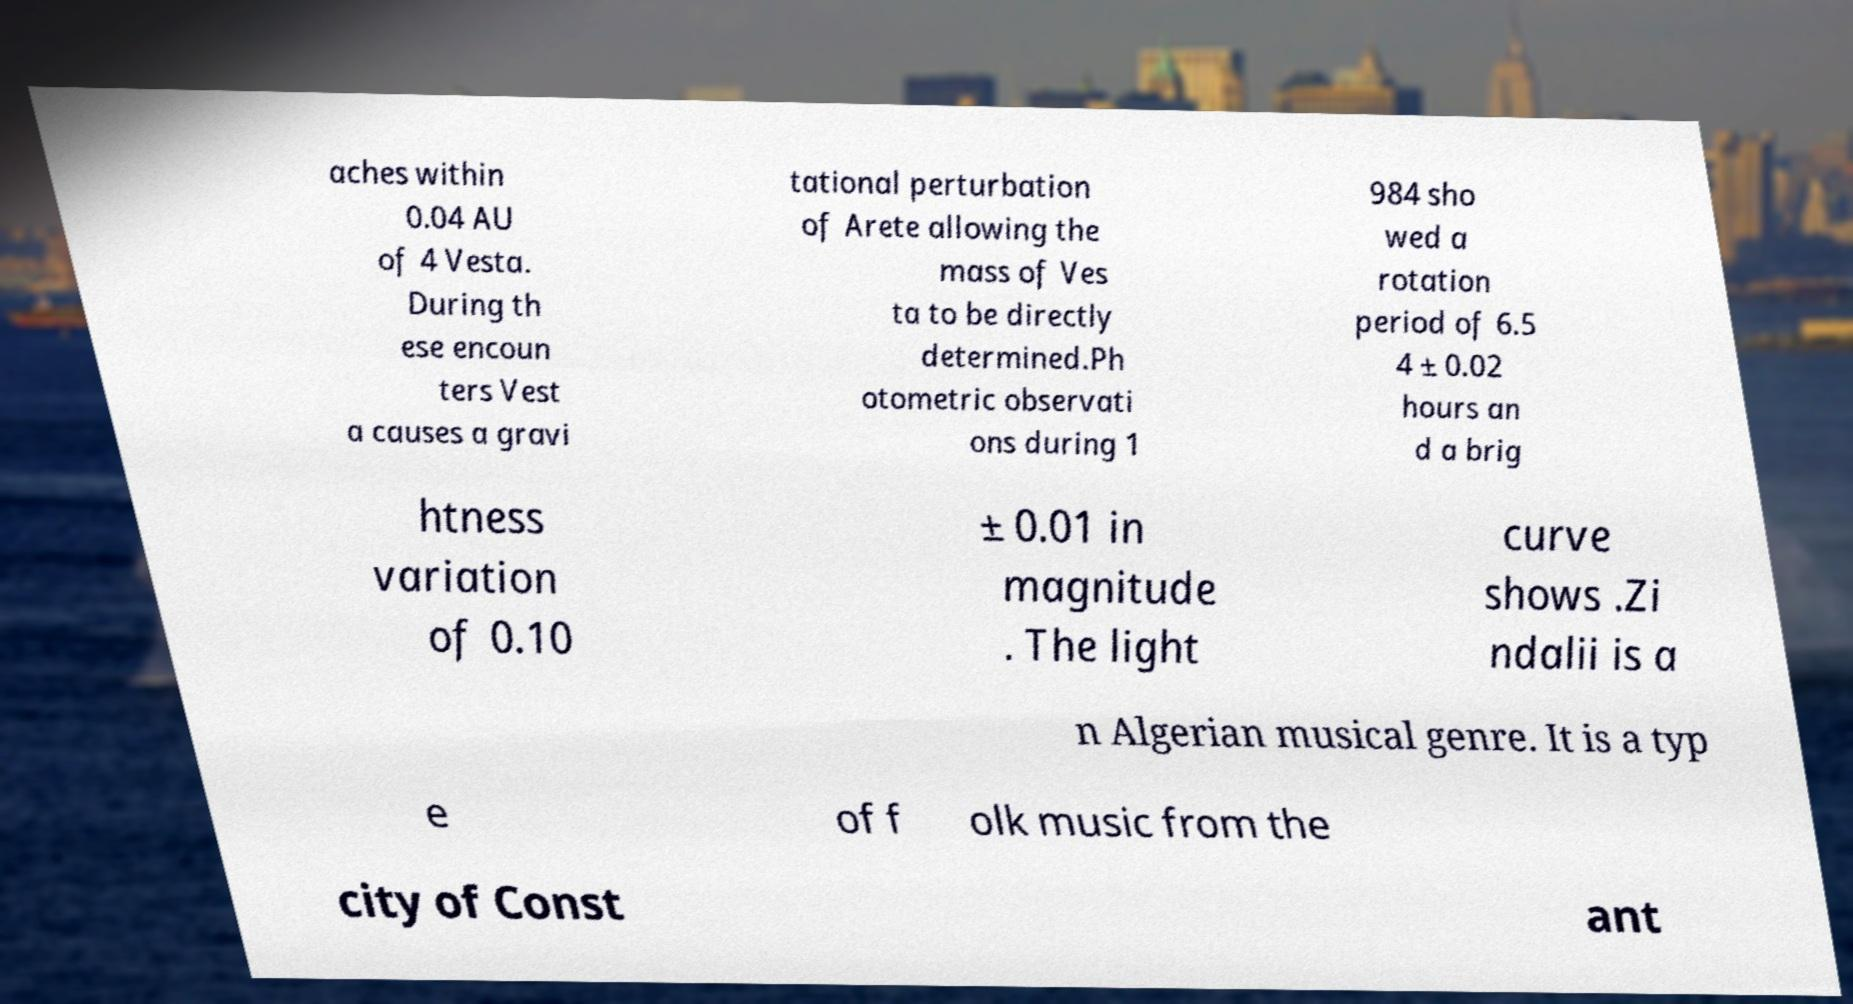Could you extract and type out the text from this image? aches within 0.04 AU of 4 Vesta. During th ese encoun ters Vest a causes a gravi tational perturbation of Arete allowing the mass of Ves ta to be directly determined.Ph otometric observati ons during 1 984 sho wed a rotation period of 6.5 4 ± 0.02 hours an d a brig htness variation of 0.10 ± 0.01 in magnitude . The light curve shows .Zi ndalii is a n Algerian musical genre. It is a typ e of f olk music from the city of Const ant 